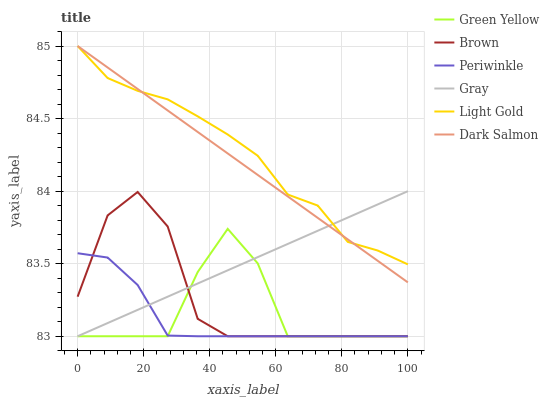Does Gray have the minimum area under the curve?
Answer yes or no. No. Does Gray have the maximum area under the curve?
Answer yes or no. No. Is Gray the smoothest?
Answer yes or no. No. Is Gray the roughest?
Answer yes or no. No. Does Dark Salmon have the lowest value?
Answer yes or no. No. Does Gray have the highest value?
Answer yes or no. No. Is Brown less than Light Gold?
Answer yes or no. Yes. Is Dark Salmon greater than Green Yellow?
Answer yes or no. Yes. Does Brown intersect Light Gold?
Answer yes or no. No. 